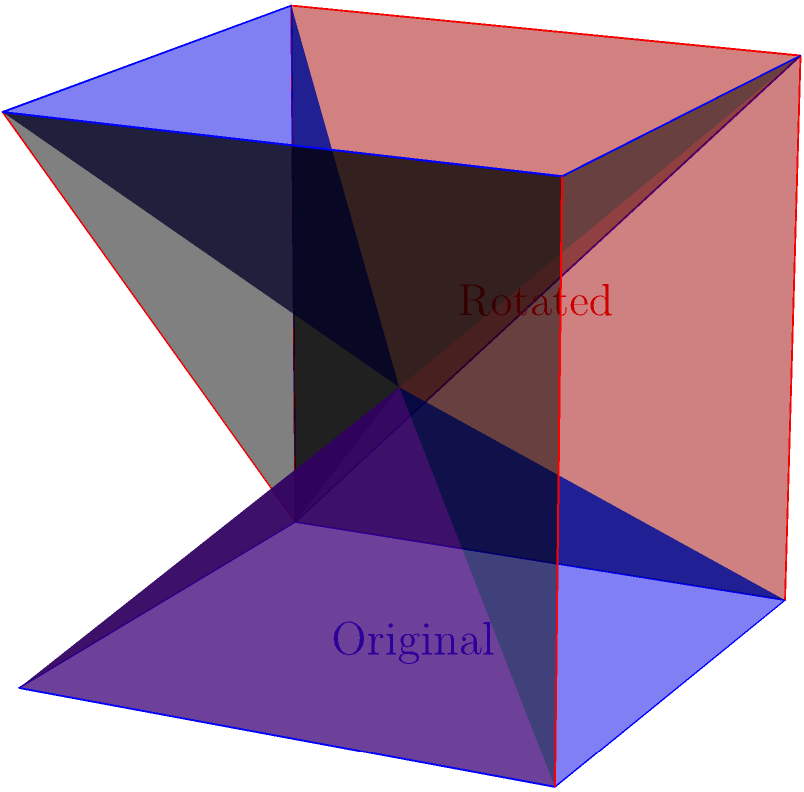Consider the blue cube shown in the figure. If this cube is rotated 120 degrees around the axis passing through opposite vertices (1,1,1) and (0,0,0), which of the following statements is true about its final position (shown in red)?

A) The face originally on the xy-plane is now parallel to the yz-plane
B) The face originally on the xy-plane is now parallel to the xz-plane
C) The face originally on the xy-plane is now parallel to a plane that makes equal angles with the x, y, and z axes
D) The face originally on the xy-plane remains parallel to the xy-plane To solve this problem, let's follow these steps:

1) First, we need to understand the rotation axis. It passes through opposite vertices of the cube, from (0,0,0) to (1,1,1). This axis makes equal angles with all three coordinate axes.

2) The rotation is 120 degrees around this axis. 120 degrees is significant because it's one-third of a full rotation (360 degrees).

3) When we rotate an object 120 degrees around an axis that makes equal angles with x, y, and z axes, we're essentially cycling the x, y, and z coordinates. Each face of the cube will take the place of another face.

4) The face originally on the xy-plane (z=0) will, after rotation, occupy a position that makes equal angles with all three coordinate planes.

5) This means that the rotated face is not parallel to any of the coordinate planes (xy, yz, or xz).

6) Instead, it will be parallel to a plane that makes equal angles with the x, y, and z axes.

Therefore, the correct answer is option C. The face originally on the xy-plane is now parallel to a plane that makes equal angles with the x, y, and z axes.
Answer: C 